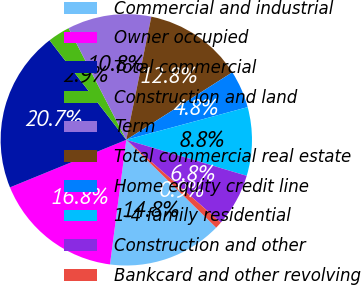<chart> <loc_0><loc_0><loc_500><loc_500><pie_chart><fcel>Commercial and industrial<fcel>Owner occupied<fcel>Total commercial<fcel>Construction and land<fcel>Term<fcel>Total commercial real estate<fcel>Home equity credit line<fcel>1-4 family residential<fcel>Construction and other<fcel>Bankcard and other revolving<nl><fcel>14.76%<fcel>16.75%<fcel>20.72%<fcel>2.86%<fcel>10.79%<fcel>12.78%<fcel>4.84%<fcel>8.81%<fcel>6.82%<fcel>0.87%<nl></chart> 